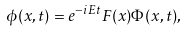Convert formula to latex. <formula><loc_0><loc_0><loc_500><loc_500>\phi ( x , t ) = e ^ { - i E t } F ( x ) \Phi ( x , t ) ,</formula> 